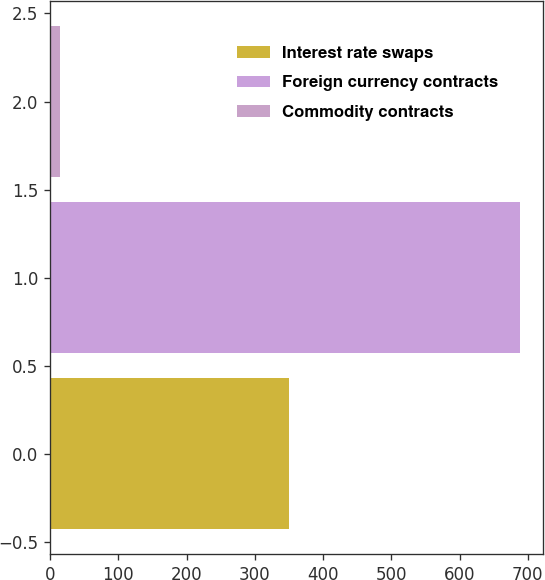<chart> <loc_0><loc_0><loc_500><loc_500><bar_chart><fcel>Interest rate swaps<fcel>Foreign currency contracts<fcel>Commodity contracts<nl><fcel>350<fcel>688<fcel>14.5<nl></chart> 